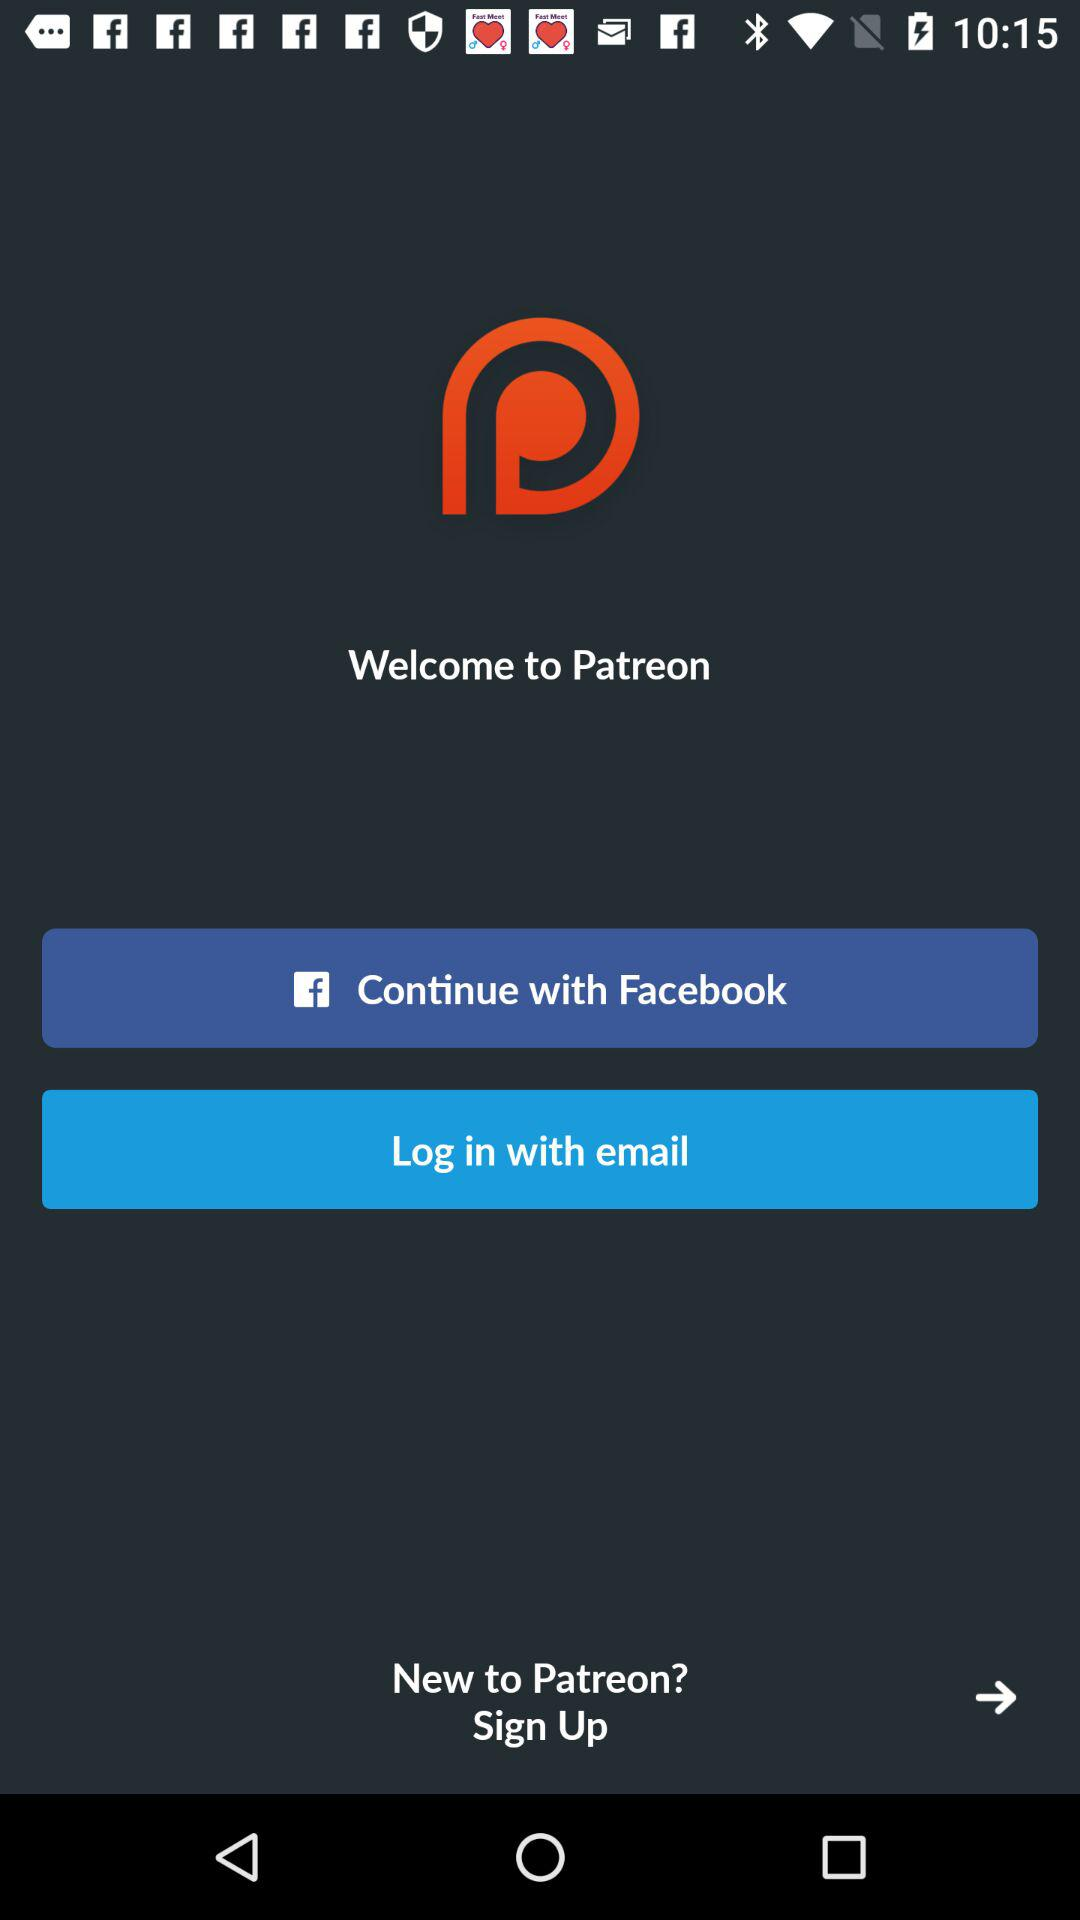What is the application name? The application name is "PATREON". 